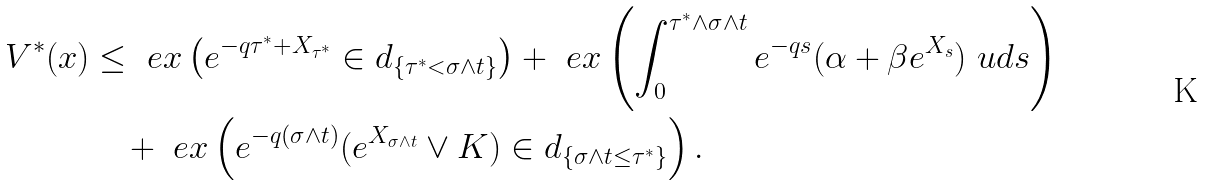Convert formula to latex. <formula><loc_0><loc_0><loc_500><loc_500>V ^ { * } ( x ) & \leq \ e x \left ( e ^ { - q \tau ^ { * } + X _ { \tau ^ { * } } } \in d _ { \{ \tau ^ { * } < \sigma \land t \} } \right ) + \ e x \left ( \int _ { 0 } ^ { \tau ^ { * } \land \sigma \land t } e ^ { - q s } ( \alpha + \beta e ^ { X _ { s } } ) \ u d s \right ) \\ & \quad + \ e x \left ( e ^ { - q ( \sigma \land t ) } ( e ^ { X _ { \sigma \land t } } \lor K ) \in d _ { \{ \sigma \land t \leq \tau ^ { * } \} } \right ) .</formula> 